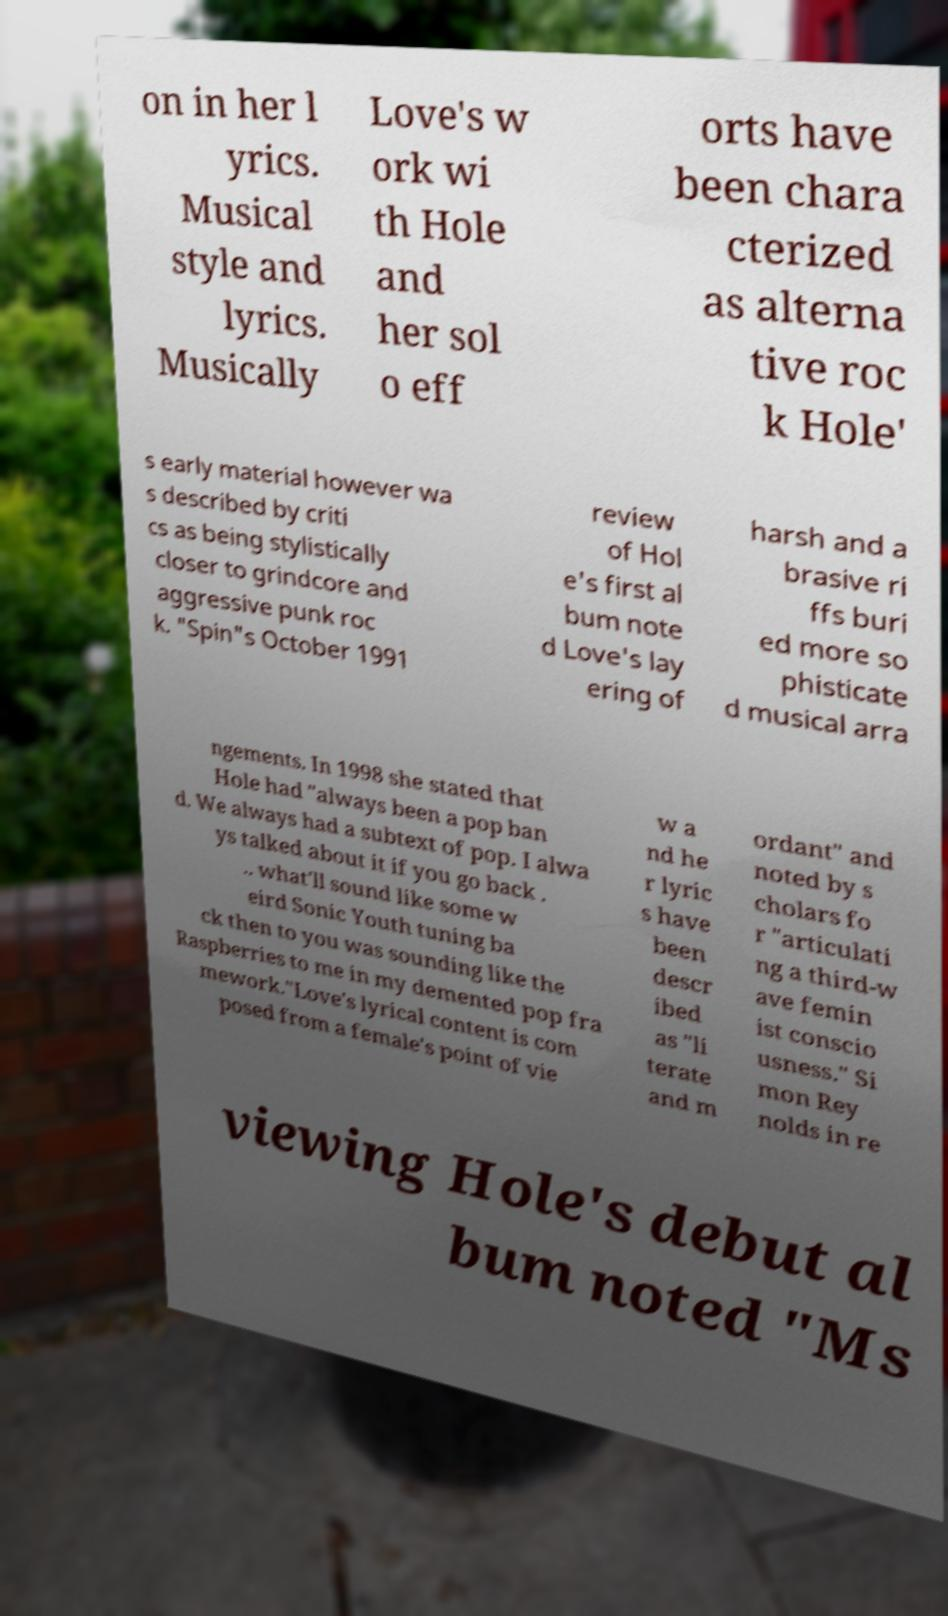Please read and relay the text visible in this image. What does it say? on in her l yrics. Musical style and lyrics. Musically Love's w ork wi th Hole and her sol o eff orts have been chara cterized as alterna tive roc k Hole' s early material however wa s described by criti cs as being stylistically closer to grindcore and aggressive punk roc k. "Spin"s October 1991 review of Hol e's first al bum note d Love's lay ering of harsh and a brasive ri ffs buri ed more so phisticate d musical arra ngements. In 1998 she stated that Hole had "always been a pop ban d. We always had a subtext of pop. I alwa ys talked about it if you go back . .. what'll sound like some w eird Sonic Youth tuning ba ck then to you was sounding like the Raspberries to me in my demented pop fra mework."Love's lyrical content is com posed from a female's point of vie w a nd he r lyric s have been descr ibed as "li terate and m ordant" and noted by s cholars fo r "articulati ng a third-w ave femin ist conscio usness." Si mon Rey nolds in re viewing Hole's debut al bum noted "Ms 